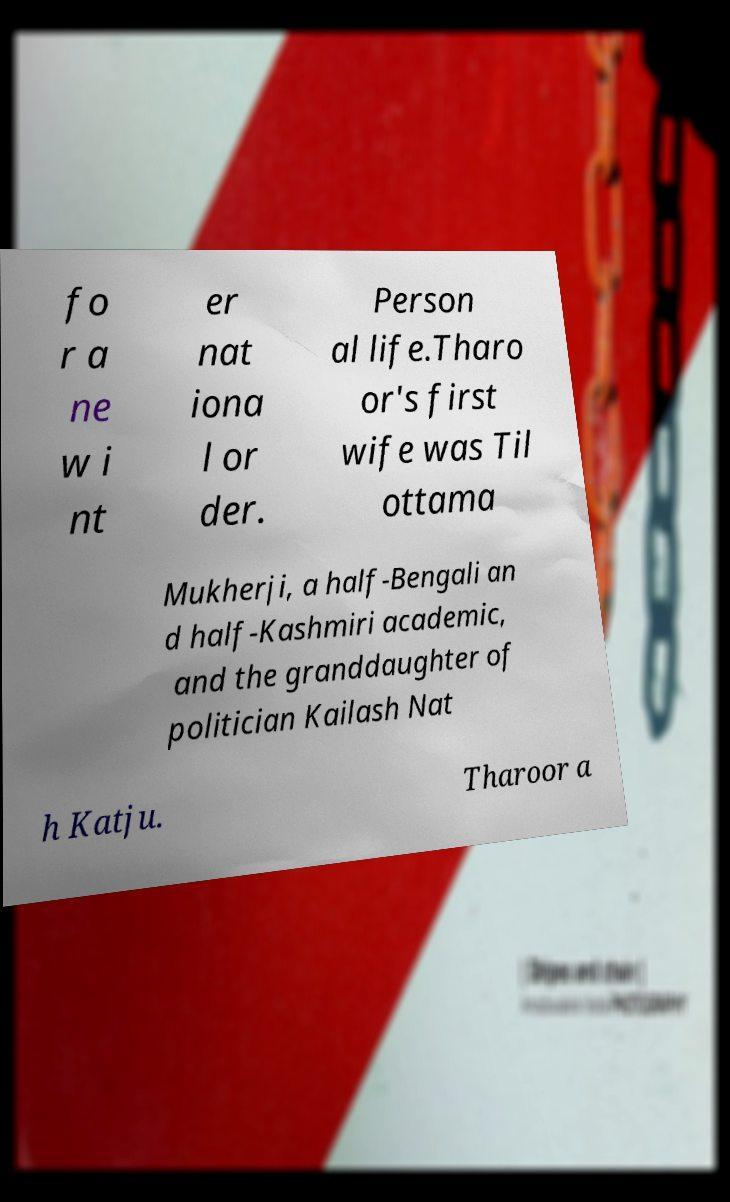Could you assist in decoding the text presented in this image and type it out clearly? fo r a ne w i nt er nat iona l or der. Person al life.Tharo or's first wife was Til ottama Mukherji, a half-Bengali an d half-Kashmiri academic, and the granddaughter of politician Kailash Nat h Katju. Tharoor a 